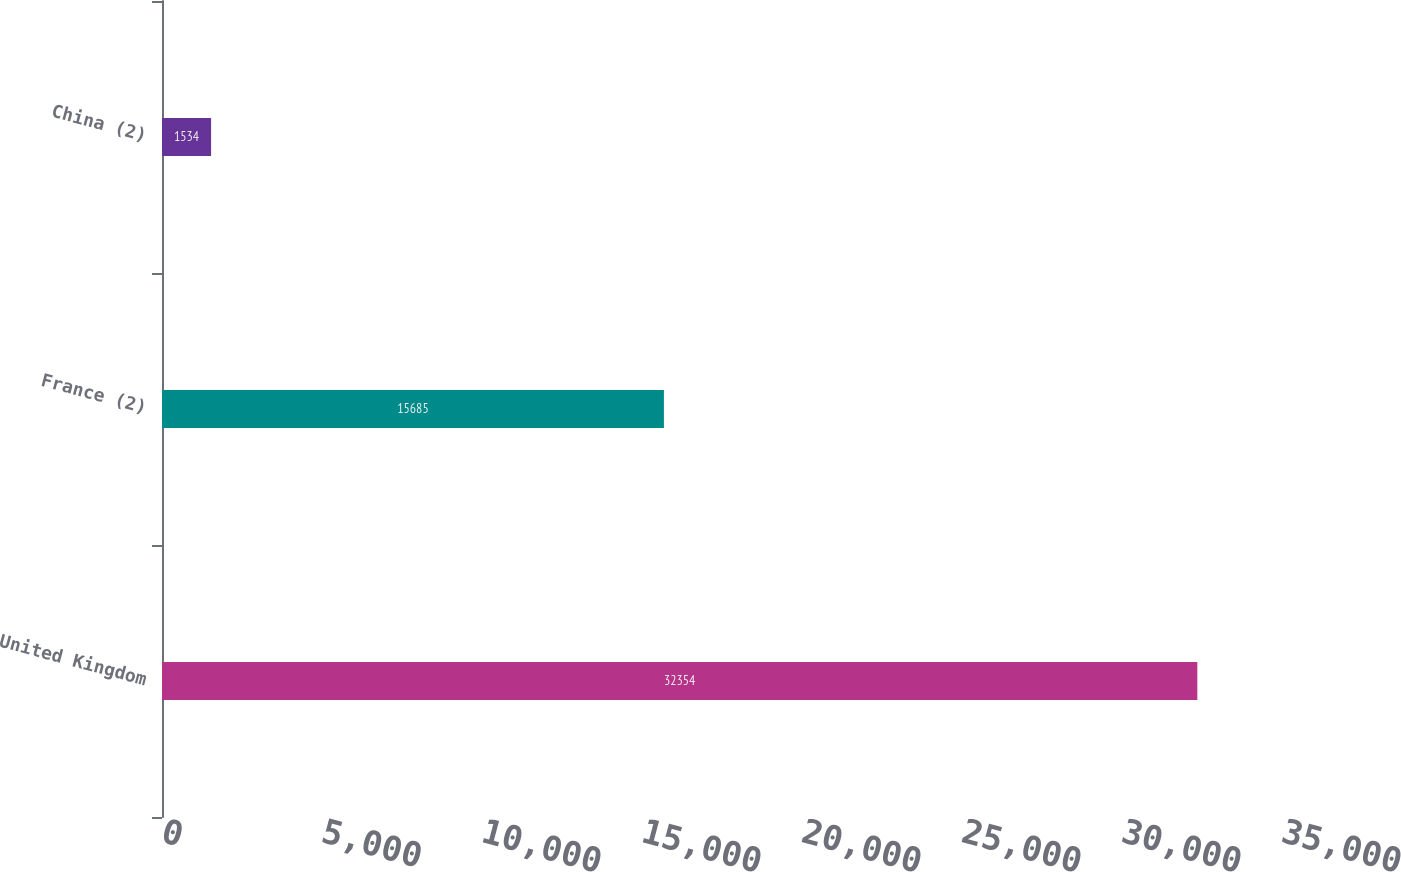Convert chart. <chart><loc_0><loc_0><loc_500><loc_500><bar_chart><fcel>United Kingdom<fcel>France (2)<fcel>China (2)<nl><fcel>32354<fcel>15685<fcel>1534<nl></chart> 